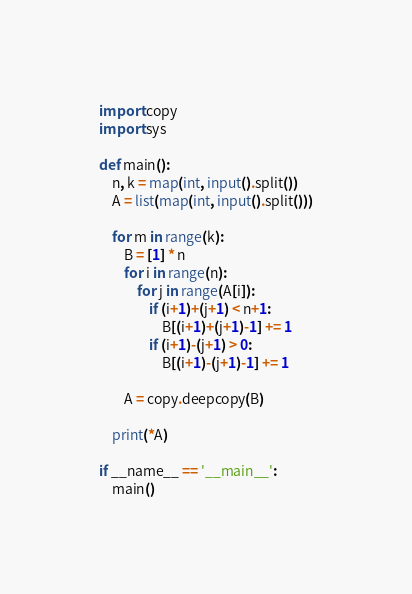Convert code to text. <code><loc_0><loc_0><loc_500><loc_500><_Python_>import copy
import sys

def main():
    n, k = map(int, input().split())
    A = list(map(int, input().split()))

    for m in range(k):
        B = [1] * n
        for i in range(n):
            for j in range(A[i]):
                if (i+1)+(j+1) < n+1:
                    B[(i+1)+(j+1)-1] += 1
                if (i+1)-(j+1) > 0:
                    B[(i+1)-(j+1)-1] += 1

        A = copy.deepcopy(B)

    print(*A)

if __name__ == '__main__':
    main()</code> 